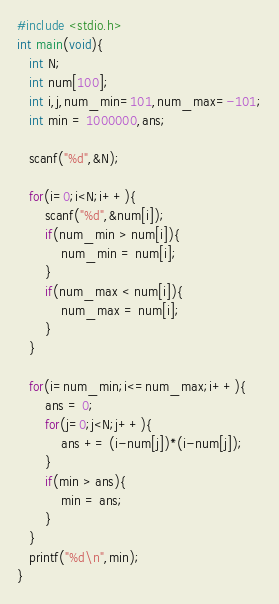<code> <loc_0><loc_0><loc_500><loc_500><_C++_>#include <stdio.h>
int main(void){
   int N;
   int num[100];
   int i,j,num_min=101,num_max=-101;
   int min = 1000000,ans;
   
   scanf("%d",&N);
   
   for(i=0;i<N;i++){
       scanf("%d",&num[i]);
       if(num_min > num[i]){
           num_min = num[i];
       }
       if(num_max < num[i]){
           num_max = num[i];
       }
   }
   
   for(i=num_min;i<=num_max;i++){
       ans = 0;
       for(j=0;j<N;j++){
           ans += (i-num[j])*(i-num[j]);
       }
       if(min > ans){
           min = ans;
       }
   }
   printf("%d\n",min);
}
</code> 